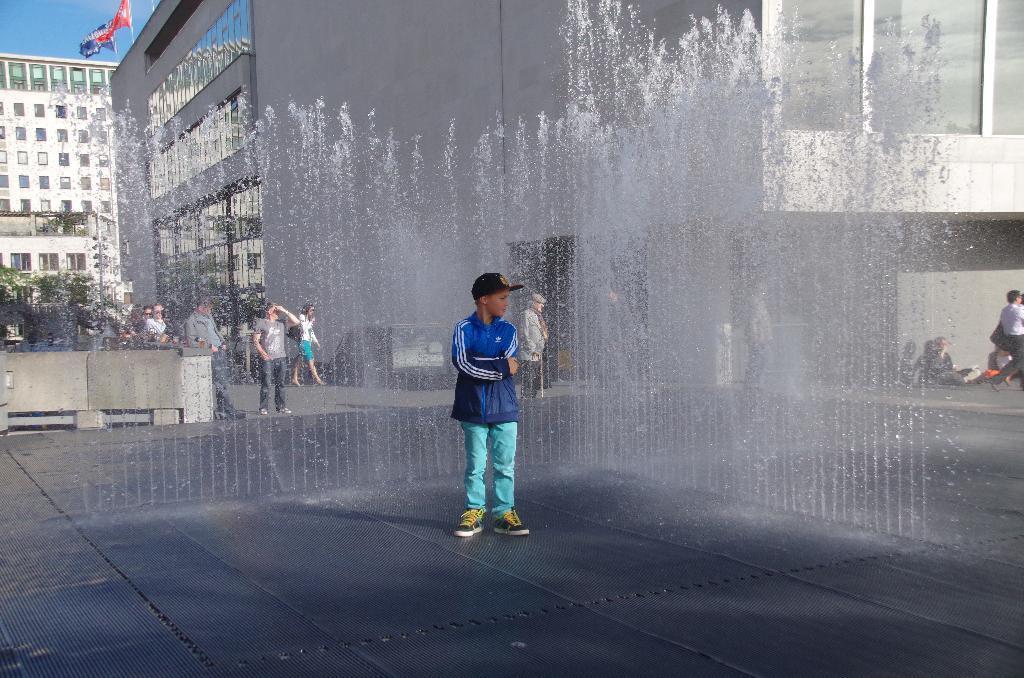Describe this image in one or two sentences. In this image we can see a person wearing blue color jacket sky blue jeans standing near the water fountain and in the background of the image there are some persons standing, walking and there are some buildings, trees and top of the building there are some flags. 